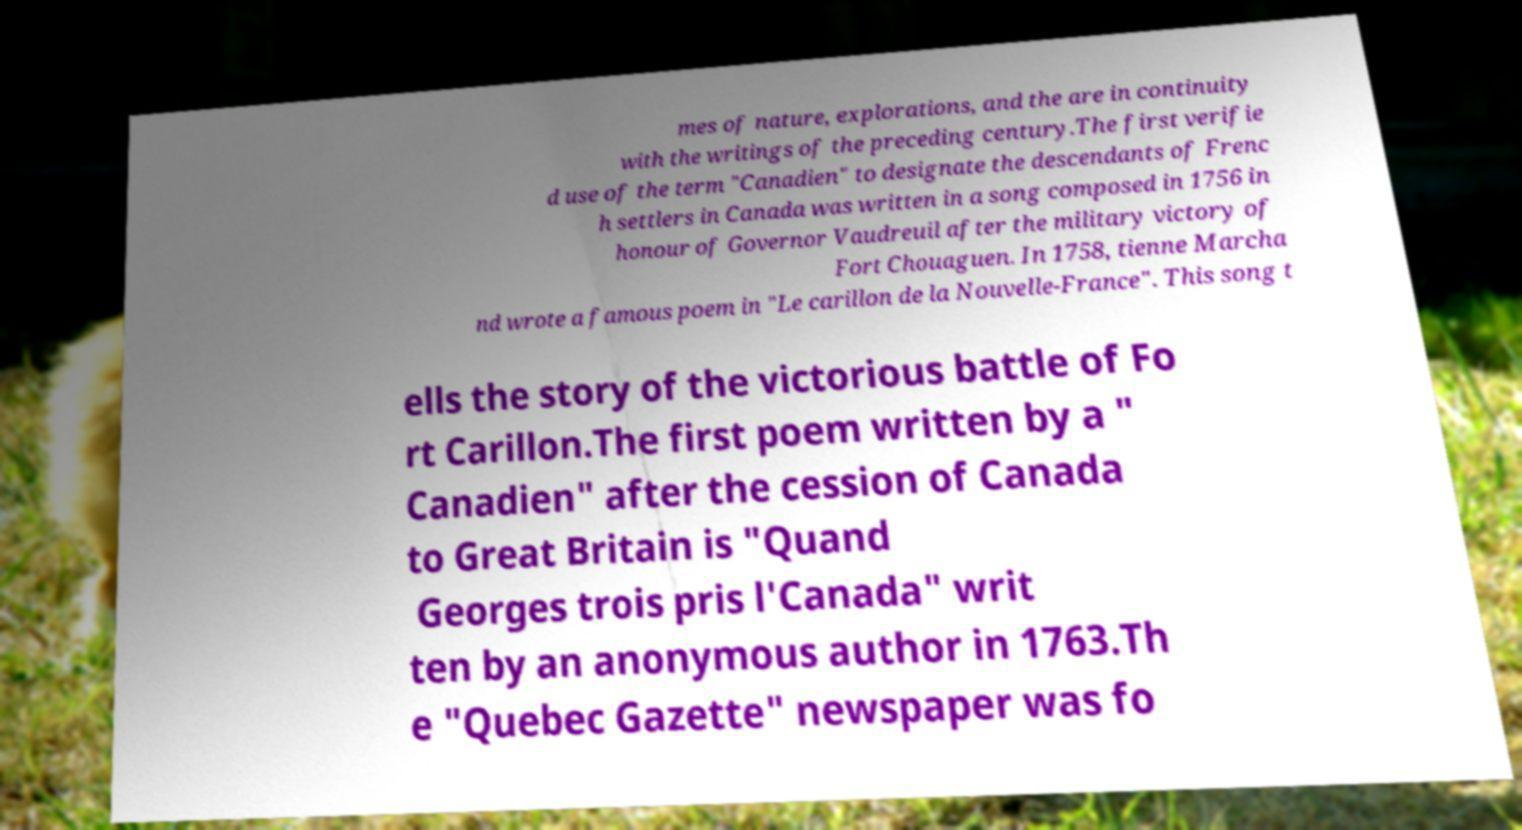I need the written content from this picture converted into text. Can you do that? mes of nature, explorations, and the are in continuity with the writings of the preceding century.The first verifie d use of the term "Canadien" to designate the descendants of Frenc h settlers in Canada was written in a song composed in 1756 in honour of Governor Vaudreuil after the military victory of Fort Chouaguen. In 1758, tienne Marcha nd wrote a famous poem in "Le carillon de la Nouvelle-France". This song t ells the story of the victorious battle of Fo rt Carillon.The first poem written by a " Canadien" after the cession of Canada to Great Britain is "Quand Georges trois pris l'Canada" writ ten by an anonymous author in 1763.Th e "Quebec Gazette" newspaper was fo 